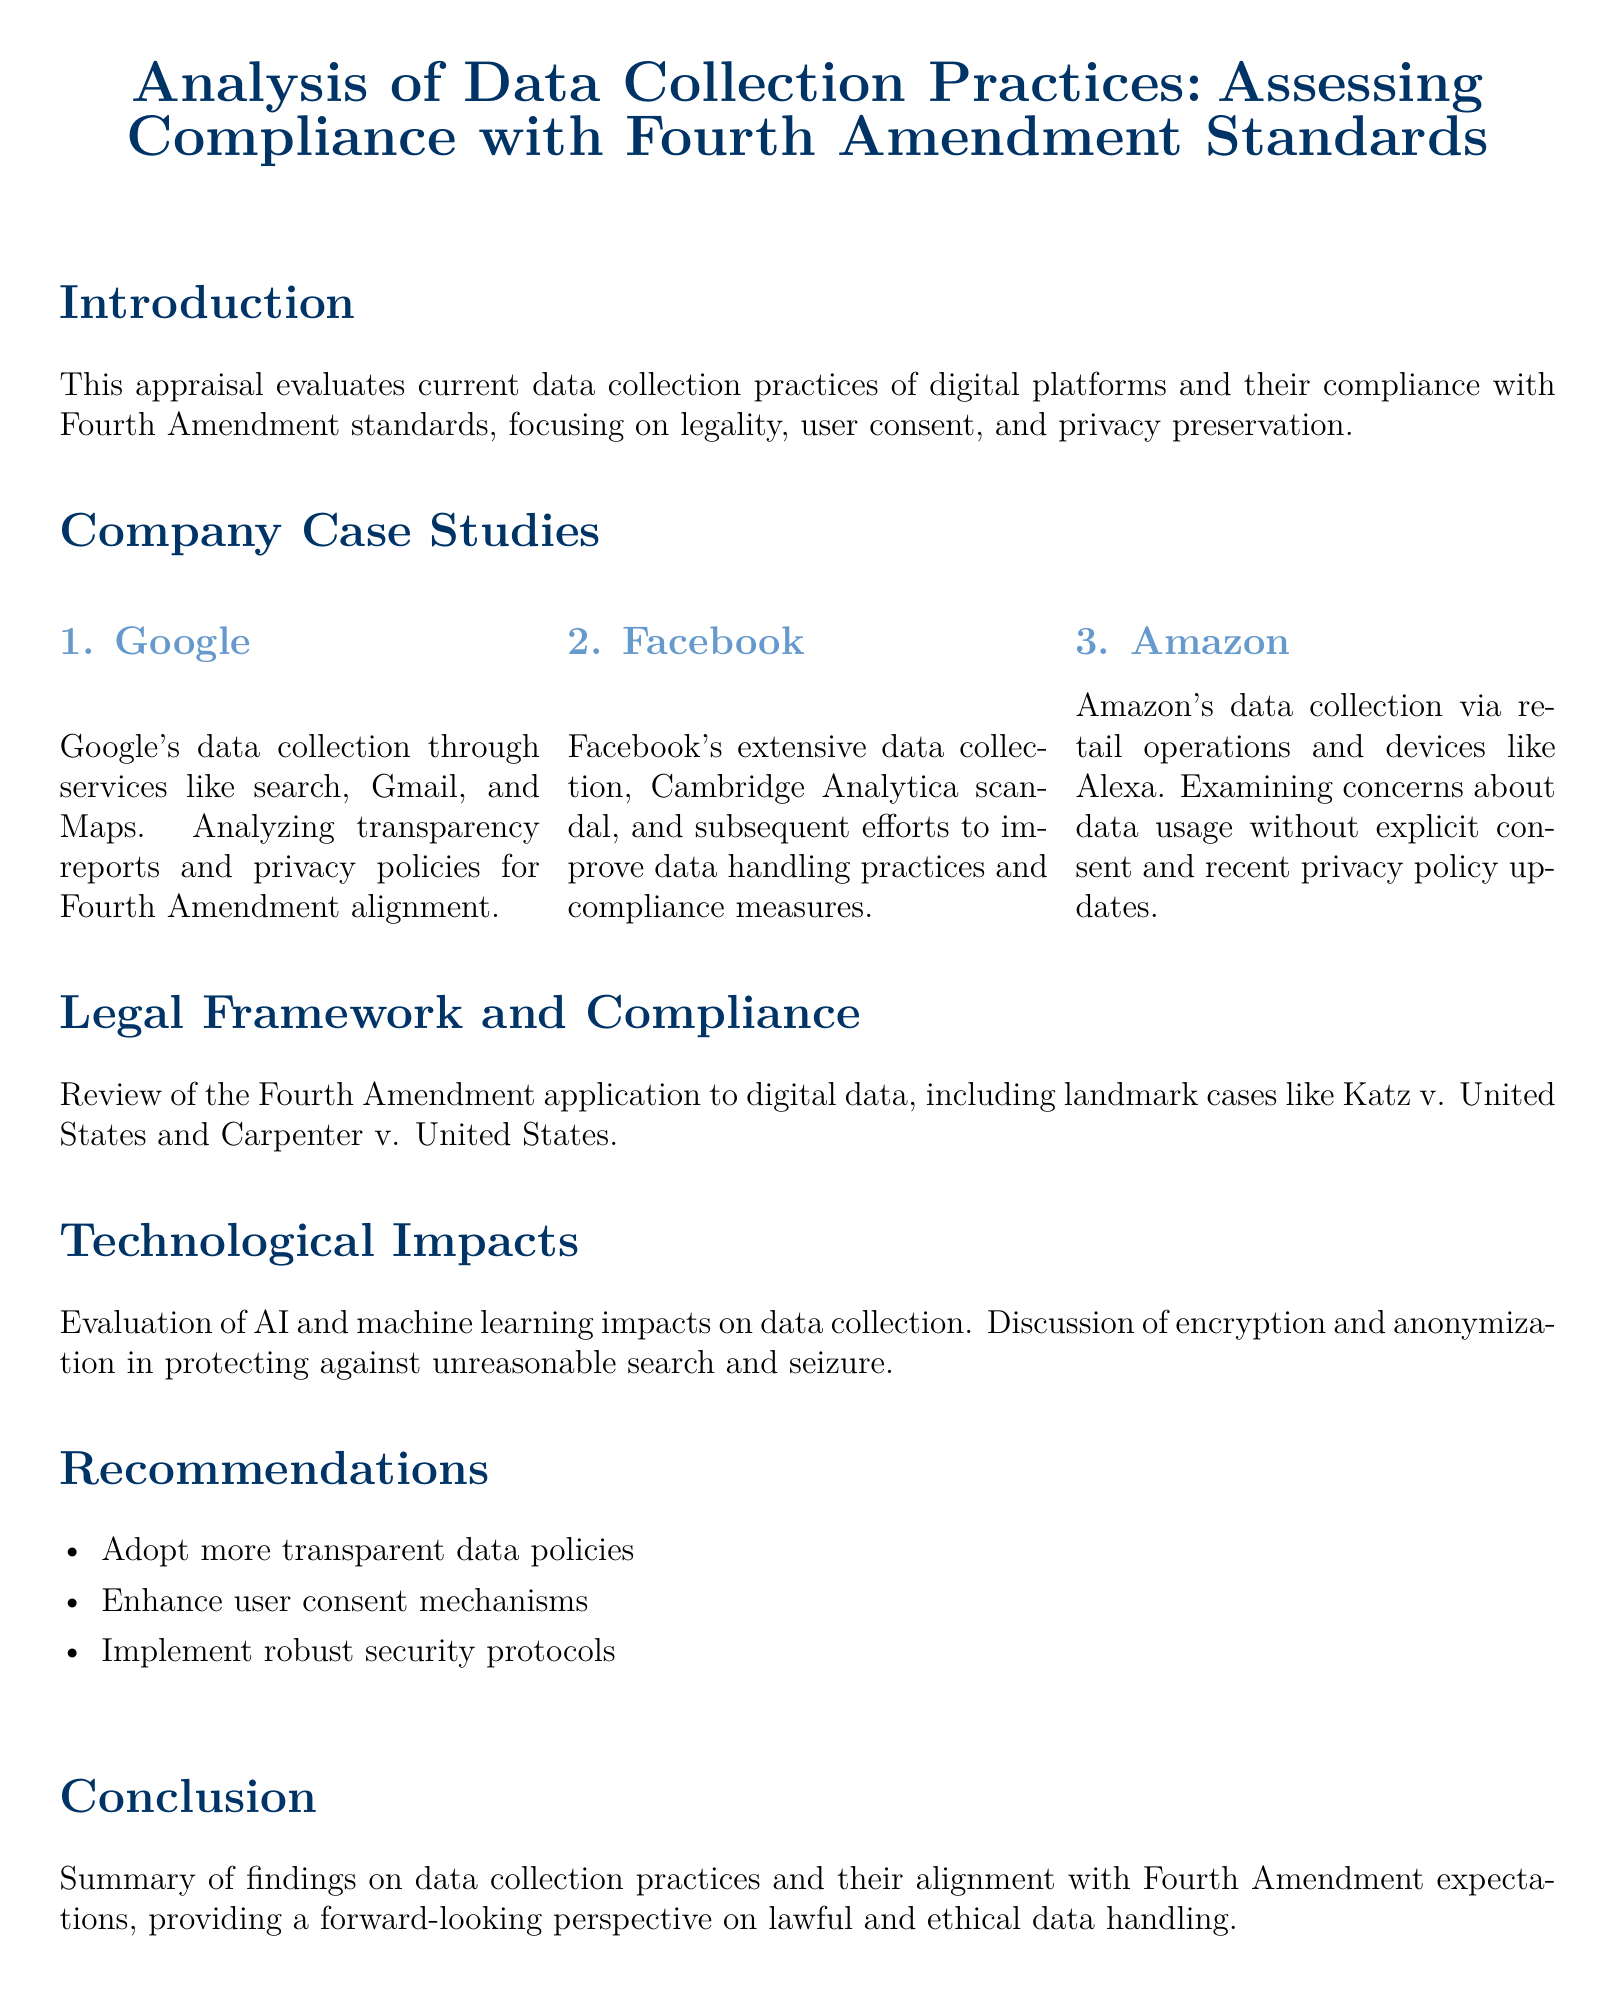What are the three company case studies mentioned? The document lists Google, Facebook, and Amazon as the company case studies being analyzed for data collection practices.
Answer: Google, Facebook, Amazon What legal framework is reviewed in the document? The document states that it reviews the Fourth Amendment application to digital data, including landmark cases.
Answer: Fourth Amendment What is one of the recommendations given in the document? The document suggests adopting more transparent data policies as one of its recommendations.
Answer: More transparent data policies Which significant scandal is associated with Facebook? The document mentions the Cambridge Analytica scandal as a notable event affecting Facebook's data practices.
Answer: Cambridge Analytica scandal In what section is the evaluation of technological impacts discussed? The evaluation of AI and machine learning impacts on data collection is discussed in the Technological Impacts section.
Answer: Technological Impacts What does the conclusion summarize? The conclusion summarizes findings on data collection practices and their alignment with Fourth Amendment expectations.
Answer: Findings on data collection practices What is the color theme used in the document? The document predominantly uses the color scheme of main color as RGB 0,51,102 and second color as RGB 102,153,204.
Answer: Main color RGB 0,51,102; second color RGB 102,153,204 How many subsections are there under company case studies? There are three subsections listed under the company case studies section.
Answer: Three 